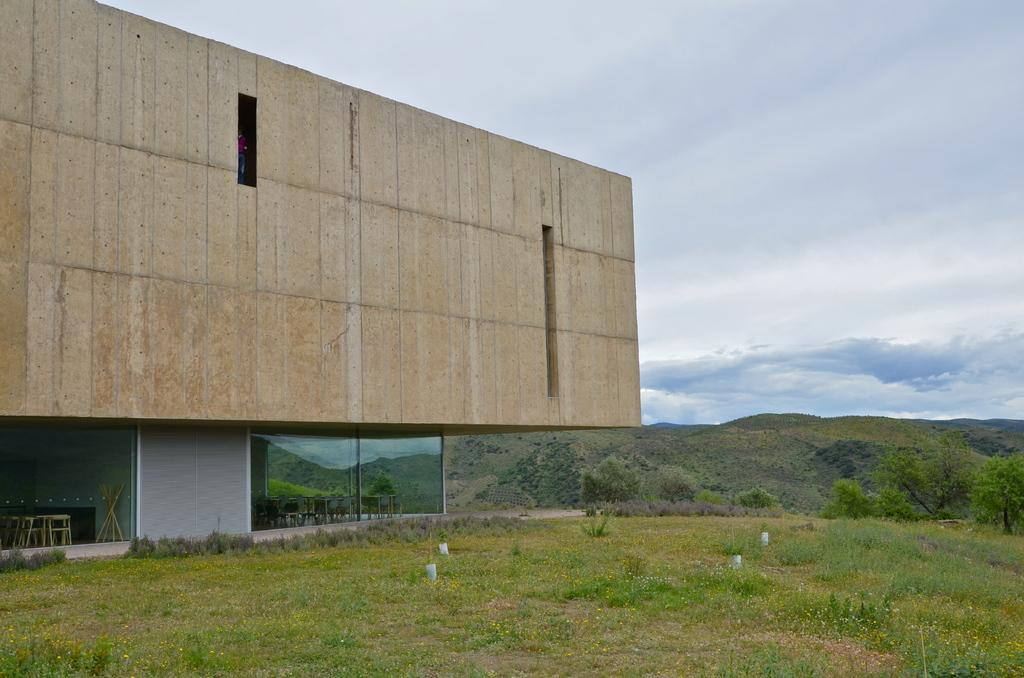What type of structure is present in the image? There is a building in the image. How would you describe the weather based on the image? The sky is cloudy in the image. What type of vegetation can be seen in the image? There is grass and trees visible in the image. Can you describe the interior of the building through the windows? Tables and chairs are visible through the glass windows in the image. What type of cork can be seen floating in the water in the image? There is no water or cork present in the image; it features a building with cloudy skies and vegetation. 